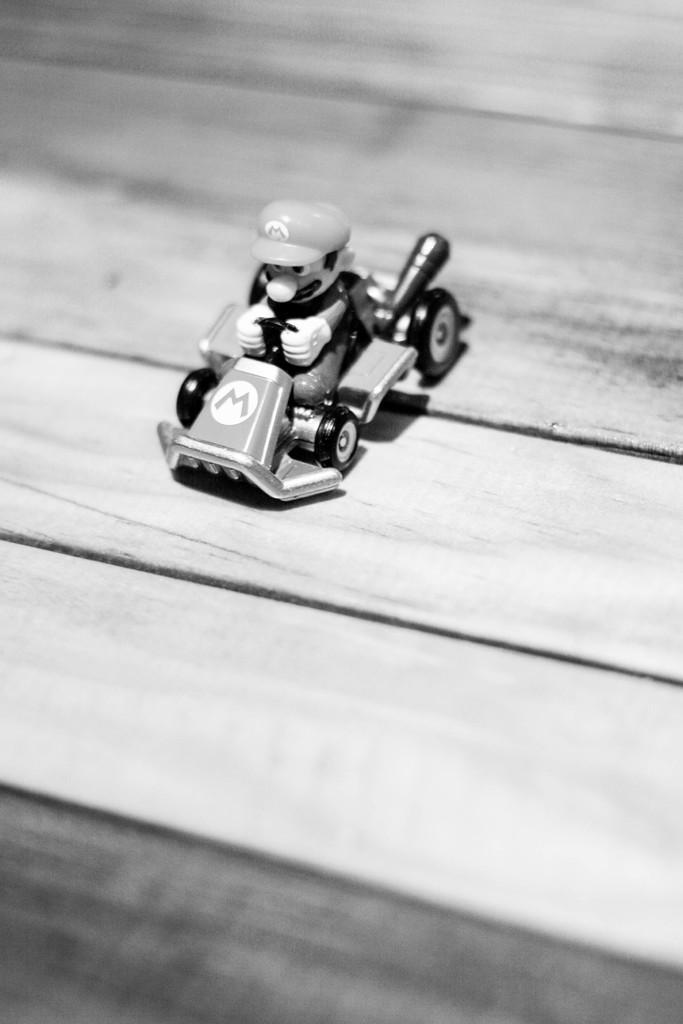Can you describe this image briefly? In this picture we can see a toy of vehicle riding a man and this is on a wooden plank. 